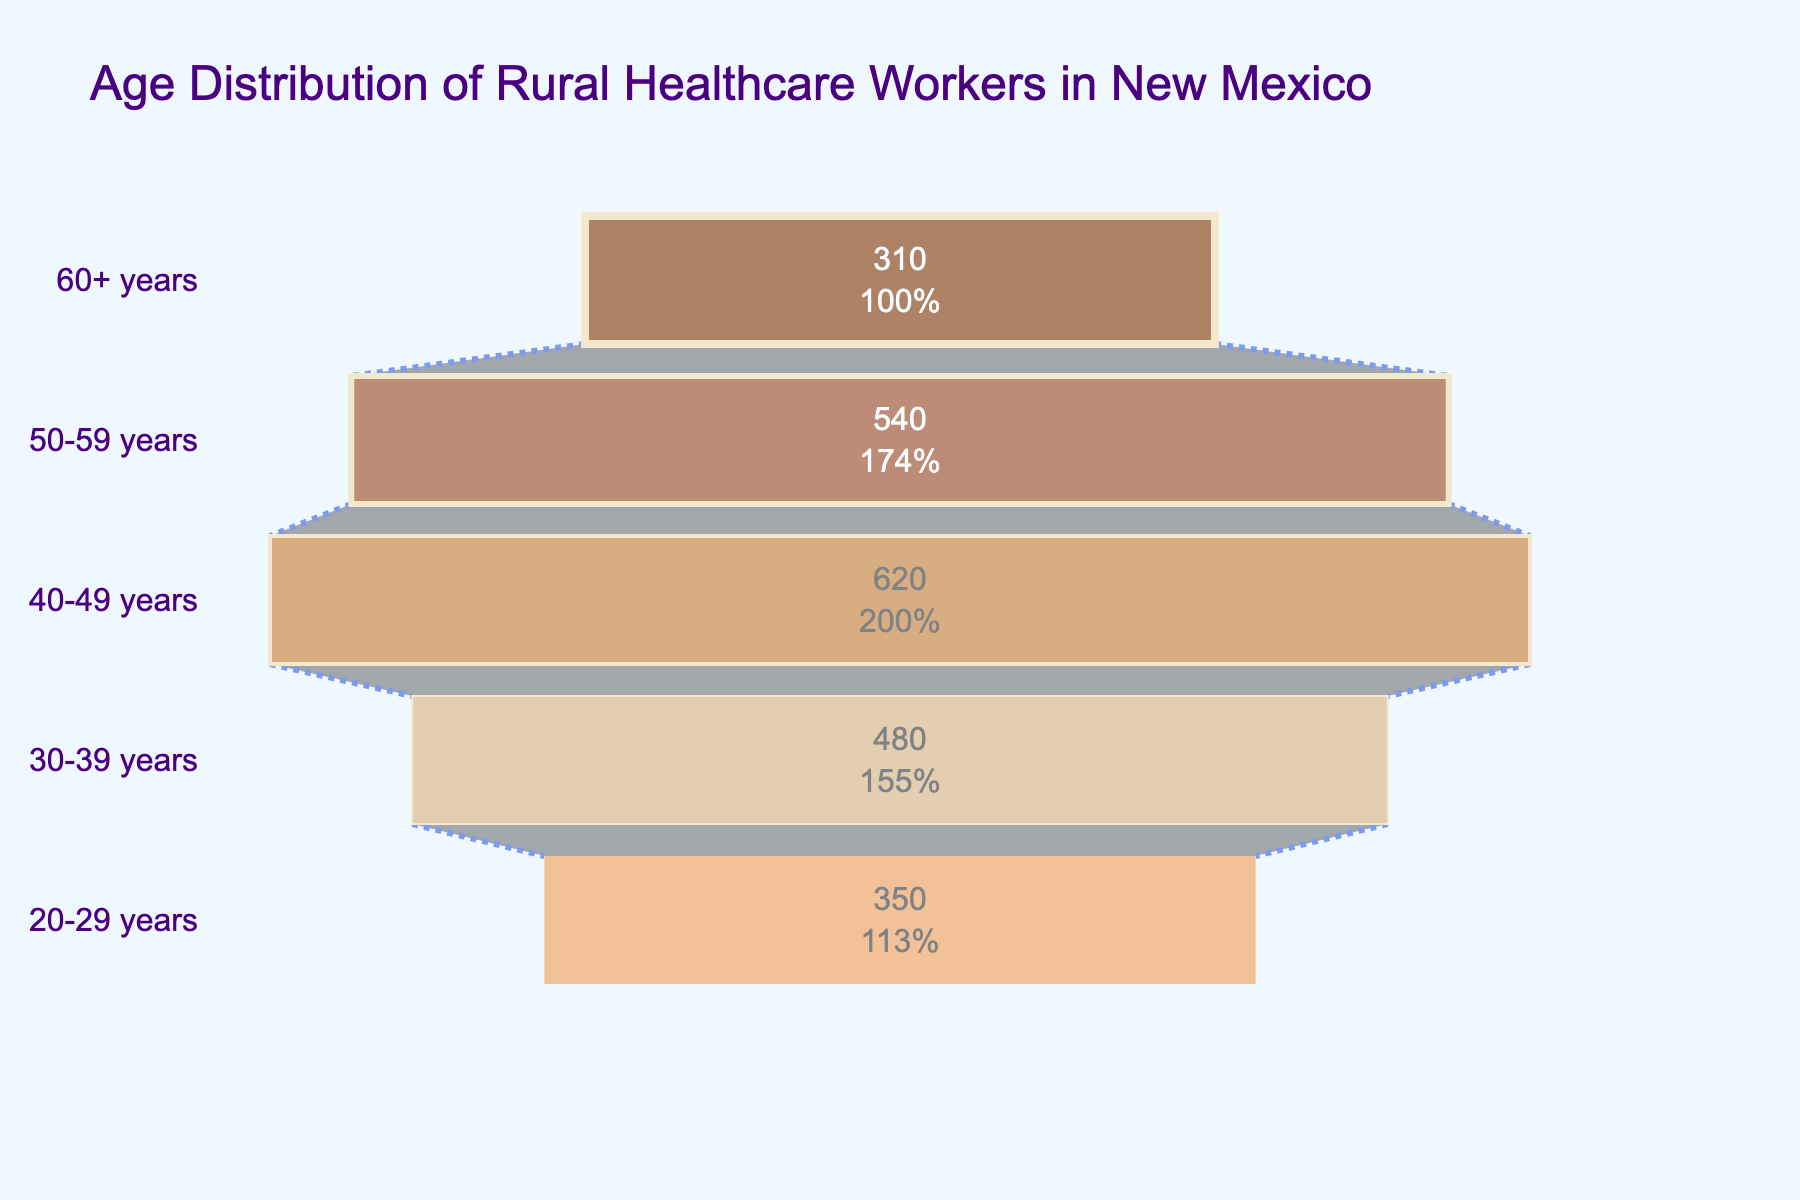What is the title of the funnel chart? The title is displayed at the top of the chart and provides an overview of what the chart is about. In this case, it reads "Age Distribution of Rural Healthcare Workers in New Mexico."
Answer: Age Distribution of Rural Healthcare Workers in New Mexico Which age group has the largest number of rural healthcare workers? By observing the widest section of the funnel chart, it represents the age group with the highest number, which is the 40-49 years group.
Answer: 40-49 years What is the smallest age group of rural healthcare workers in terms of numbers? The smallest section in the funnel chart reveals the smallest age group, which is the 60+ years category.
Answer: 60+ years How many healthcare workers fall into the 30-39 years age group? The figure inside the 30-39 years section indicates the number, which is 480.
Answer: 480 Calculate the total number of rural healthcare workers represented in the chart. Add the numbers for all age groups: 350 (20-29 years) + 480 (30-39 years) + 620 (40-49 years) + 540 (50-59 years) + 310 (60+ years).
Answer: 2300 Which two age groups combined have more than 1000 healthcare workers? Summing up the data: 40-49 years (620) + 50-59 years (540) = 1160; hence, these two groups combined exceed 1000.
Answer: 40-49 years and 50-59 years What is the percentage representation of the 20-29 years age group compared to the total number of workers? Divide the number of 20-29 years (350) by the total (2300), then multiply by 100 to get the percentage: (350 / 2300) * 100 ≈ 15.22%.
Answer: 15.22% By how much does the number of workers in the 40-49 years group exceed those in the 60+ years group? Subtract the number in the 60+ years group (310) from the 40-49 years group (620): 620 - 310 = 310.
Answer: 310 Do workers aged 30-39 years outnumber those aged 50-59 years? Comparing the numbers, the 30-39 years group has 480, whereas the 50-59 years group has 540, so the latter outnumbers the former.
Answer: No What proportion of the total workforce is made up by the 50-59 years age group? The proportion is found by dividing the number in the 50-59 years group (540) by the total (2300), then multiplying by 100: (540 / 2300) * 100 ≈ 23.48%.
Answer: 23.48% 